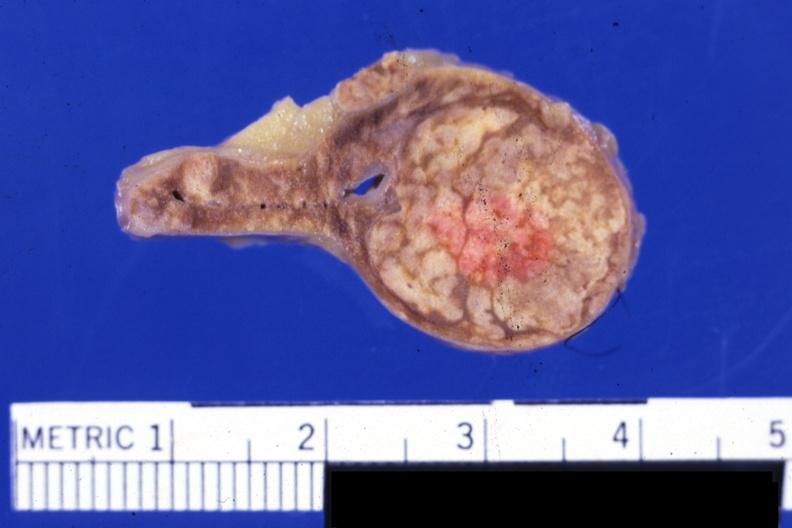s cortical nodule present?
Answer the question using a single word or phrase. Yes 